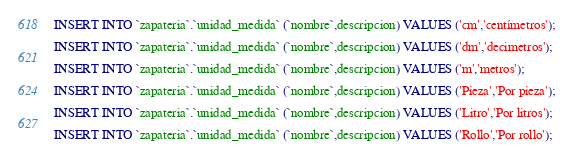<code> <loc_0><loc_0><loc_500><loc_500><_SQL_>INSERT INTO `zapateria`.`unidad_medida` (`nombre`,descripcion) VALUES ('cm','centímetros');

INSERT INTO `zapateria`.`unidad_medida` (`nombre`,descripcion) VALUES ('dm','decimetros');

INSERT INTO `zapateria`.`unidad_medida` (`nombre`,descripcion) VALUES ('m','metros');

INSERT INTO `zapateria`.`unidad_medida` (`nombre`,descripcion) VALUES ('Pieza','Por pieza');

INSERT INTO `zapateria`.`unidad_medida` (`nombre`,descripcion) VALUES ('Litro','Por litros');

INSERT INTO `zapateria`.`unidad_medida` (`nombre`,descripcion) VALUES ('Rollo','Por rollo');</code> 